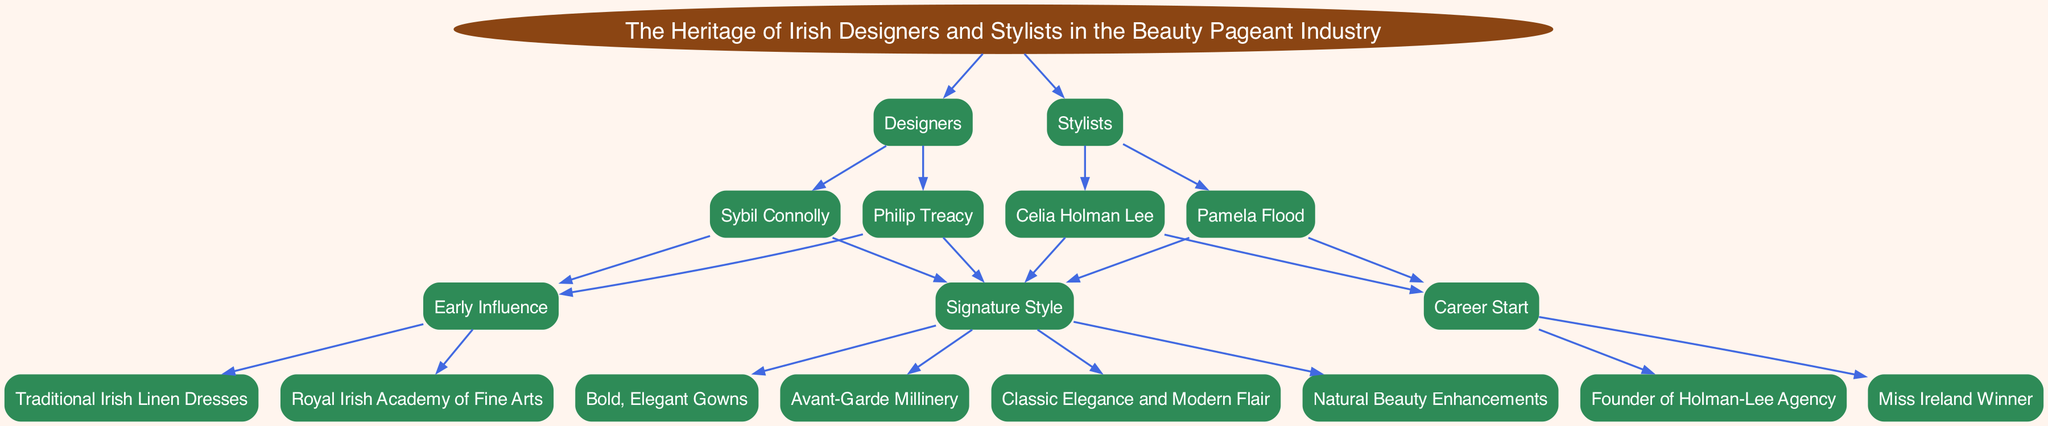What are the two main branches of designers and stylists in the diagram? The diagram has two main branches labeled "Designers" and "Stylists," clearly indicating the categories within the beauty pageant industry heritage.
Answer: Designers, Stylists Who is a stylist that started her career as a Miss Ireland winner? The diagram provides the name of Pamela Flood, who is listed under Stylists and has "Miss Ireland Winner" as her career start.
Answer: Pamela Flood What is Philip Treacy's signature style? The diagram states that Philip Treacy's signature style is "Avant-Garde Millinery," and this can be found in the section detailing his contributions to the beauty pageant industry.
Answer: Avant-Garde Millinery How many children does Sybil Connolly have in the diagram? Sybil Connolly has two children in the diagram: "Early Influence" and "Signature Style," making it clear how her designs are influenced and characterized.
Answer: 2 What type of influence is associated with Celia Holman Lee? The diagram highlights that Celia Holman Lee's early influence is the "Founder of Holman-Lee Agency," establishing her foundational role in the stylists' category.
Answer: Founder of Holman-Lee Agency Which designer is known for traditional Irish linen dresses? According to the diagram, Sybil Connolly is specifically recognized for "Traditional Irish Linen Dresses," reflecting her unique contribution to the design aspect of beauty pageants.
Answer: Sybil Connolly What is the total number of designers listed in the diagram? The diagram shows two designers: Sybil Connolly and Philip Treacy. By counting these entries, we can ascertain the total number of designers represented.
Answer: 2 Which stylist epitomizes classic elegance and modern flair? The diagram indicates that Celia Holman Lee represents "Classic Elegance and Modern Flair" as part of her signature style in the stylists' section.
Answer: Celia Holman Lee What is the relationship between designers and stylists in this family tree? The diagram illustrates that designers and stylists are two separate but related branches under the overarching theme of Irish heritage in the beauty pageant industry, indicating their collaborative role.
Answer: Related branches 